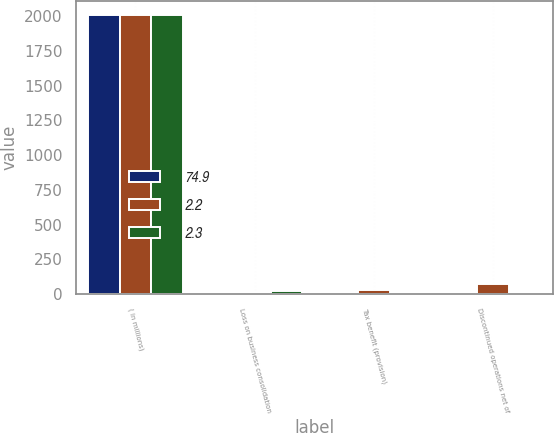Convert chart to OTSL. <chart><loc_0><loc_0><loc_500><loc_500><stacked_bar_chart><ecel><fcel>( in millions)<fcel>Loss on business consolidation<fcel>Tax benefit (provision)<fcel>Discontinued operations net of<nl><fcel>74.9<fcel>2011<fcel>3<fcel>1.5<fcel>2.3<nl><fcel>2.2<fcel>2010<fcel>10.4<fcel>30.5<fcel>74.9<nl><fcel>2.3<fcel>2009<fcel>23.1<fcel>3<fcel>2.2<nl></chart> 